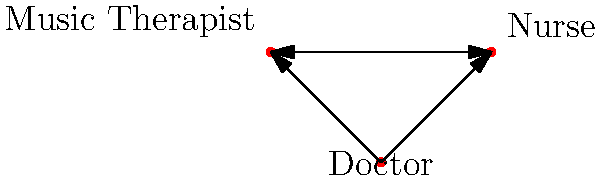In the collaborative workflow network diagram shown, which professional acts as the central hub for communication and coordination between all team members? To determine the central hub in this collaborative workflow, let's analyze the network diagram step-by-step:

1. Identify the professionals: The diagram shows three professionals - Doctor, Nurse, and Music Therapist.

2. Examine the connections:
   a. There's a one-way arrow from the Doctor to the Nurse.
   b. There's a one-way arrow from the Doctor to the Music Therapist.
   c. There's a two-way arrow between the Nurse and the Music Therapist.

3. Analyze the communication flow:
   a. The Doctor can directly communicate with both the Nurse and the Music Therapist.
   b. The Nurse and Music Therapist can communicate with each other.
   c. However, there's no direct communication from the Nurse or Music Therapist back to the Doctor.

4. Identify the central position:
   The Doctor is the only professional who has direct outgoing connections to both other team members.

5. Consider the role in coordination:
   As a medical doctor open to alternative approaches, the central position allows for initiating and coordinating the collaborative efforts between all team members.

Therefore, the Doctor acts as the central hub for communication and coordination in this collaborative workflow.
Answer: Doctor 